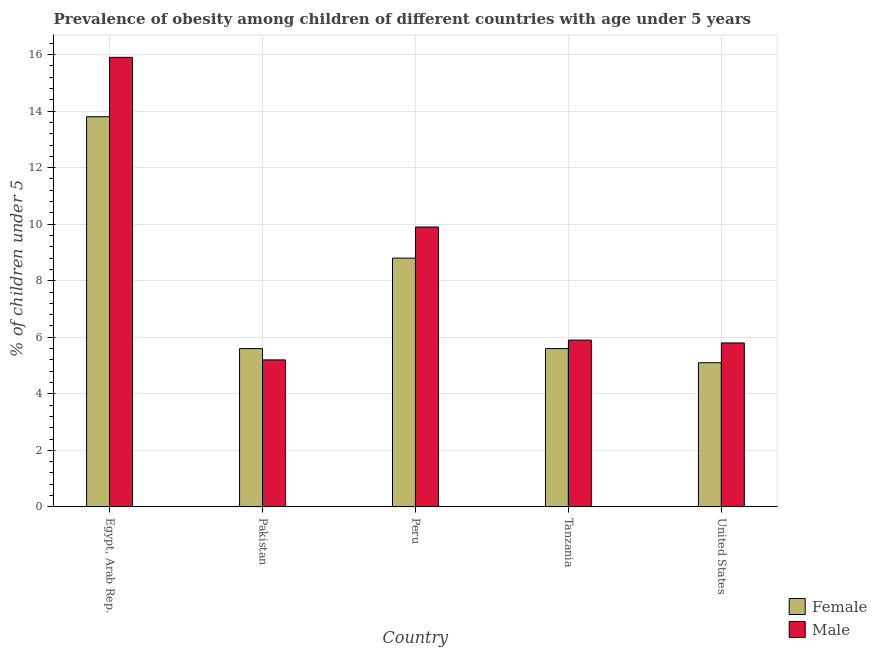How many bars are there on the 3rd tick from the left?
Ensure brevity in your answer.  2. How many bars are there on the 1st tick from the right?
Ensure brevity in your answer.  2. What is the label of the 4th group of bars from the left?
Ensure brevity in your answer.  Tanzania. In how many cases, is the number of bars for a given country not equal to the number of legend labels?
Offer a very short reply. 0. What is the percentage of obese female children in Tanzania?
Provide a short and direct response. 5.6. Across all countries, what is the maximum percentage of obese female children?
Keep it short and to the point. 13.8. Across all countries, what is the minimum percentage of obese female children?
Make the answer very short. 5.1. In which country was the percentage of obese female children maximum?
Your answer should be very brief. Egypt, Arab Rep. In which country was the percentage of obese female children minimum?
Give a very brief answer. United States. What is the total percentage of obese male children in the graph?
Keep it short and to the point. 42.7. What is the difference between the percentage of obese female children in Pakistan and that in Peru?
Give a very brief answer. -3.2. What is the difference between the percentage of obese male children in Peru and the percentage of obese female children in Tanzania?
Provide a succinct answer. 4.3. What is the average percentage of obese male children per country?
Offer a very short reply. 8.54. What is the difference between the percentage of obese female children and percentage of obese male children in Egypt, Arab Rep.?
Keep it short and to the point. -2.1. What is the ratio of the percentage of obese male children in Egypt, Arab Rep. to that in Pakistan?
Your answer should be compact. 3.06. What is the difference between the highest and the second highest percentage of obese male children?
Provide a succinct answer. 6. What is the difference between the highest and the lowest percentage of obese male children?
Your answer should be compact. 10.7. In how many countries, is the percentage of obese male children greater than the average percentage of obese male children taken over all countries?
Offer a very short reply. 2. Is the sum of the percentage of obese female children in Egypt, Arab Rep. and Tanzania greater than the maximum percentage of obese male children across all countries?
Your response must be concise. Yes. What does the 1st bar from the left in United States represents?
Offer a very short reply. Female. Are all the bars in the graph horizontal?
Ensure brevity in your answer.  No. How many countries are there in the graph?
Offer a terse response. 5. Does the graph contain grids?
Provide a short and direct response. Yes. Where does the legend appear in the graph?
Keep it short and to the point. Bottom right. How many legend labels are there?
Offer a very short reply. 2. How are the legend labels stacked?
Keep it short and to the point. Vertical. What is the title of the graph?
Your answer should be very brief. Prevalence of obesity among children of different countries with age under 5 years. What is the label or title of the Y-axis?
Give a very brief answer.  % of children under 5. What is the  % of children under 5 in Female in Egypt, Arab Rep.?
Your answer should be compact. 13.8. What is the  % of children under 5 of Male in Egypt, Arab Rep.?
Your response must be concise. 15.9. What is the  % of children under 5 of Female in Pakistan?
Your response must be concise. 5.6. What is the  % of children under 5 in Male in Pakistan?
Provide a succinct answer. 5.2. What is the  % of children under 5 of Female in Peru?
Give a very brief answer. 8.8. What is the  % of children under 5 of Male in Peru?
Give a very brief answer. 9.9. What is the  % of children under 5 in Female in Tanzania?
Offer a very short reply. 5.6. What is the  % of children under 5 in Male in Tanzania?
Your answer should be very brief. 5.9. What is the  % of children under 5 of Female in United States?
Your answer should be compact. 5.1. What is the  % of children under 5 of Male in United States?
Give a very brief answer. 5.8. Across all countries, what is the maximum  % of children under 5 in Female?
Provide a succinct answer. 13.8. Across all countries, what is the maximum  % of children under 5 of Male?
Offer a very short reply. 15.9. Across all countries, what is the minimum  % of children under 5 in Female?
Your answer should be very brief. 5.1. Across all countries, what is the minimum  % of children under 5 of Male?
Provide a short and direct response. 5.2. What is the total  % of children under 5 in Female in the graph?
Your answer should be very brief. 38.9. What is the total  % of children under 5 in Male in the graph?
Your answer should be very brief. 42.7. What is the difference between the  % of children under 5 of Female in Egypt, Arab Rep. and that in Pakistan?
Your answer should be compact. 8.2. What is the difference between the  % of children under 5 in Male in Egypt, Arab Rep. and that in Pakistan?
Your response must be concise. 10.7. What is the difference between the  % of children under 5 of Female in Egypt, Arab Rep. and that in Peru?
Your answer should be compact. 5. What is the difference between the  % of children under 5 in Male in Egypt, Arab Rep. and that in Tanzania?
Make the answer very short. 10. What is the difference between the  % of children under 5 of Female in Egypt, Arab Rep. and that in United States?
Give a very brief answer. 8.7. What is the difference between the  % of children under 5 of Male in Egypt, Arab Rep. and that in United States?
Keep it short and to the point. 10.1. What is the difference between the  % of children under 5 of Female in Pakistan and that in United States?
Your answer should be compact. 0.5. What is the difference between the  % of children under 5 of Male in Pakistan and that in United States?
Ensure brevity in your answer.  -0.6. What is the difference between the  % of children under 5 of Male in Peru and that in Tanzania?
Give a very brief answer. 4. What is the difference between the  % of children under 5 in Female in Tanzania and that in United States?
Offer a very short reply. 0.5. What is the difference between the  % of children under 5 of Female in Egypt, Arab Rep. and the  % of children under 5 of Male in Pakistan?
Provide a short and direct response. 8.6. What is the difference between the  % of children under 5 of Female in Egypt, Arab Rep. and the  % of children under 5 of Male in United States?
Keep it short and to the point. 8. What is the difference between the  % of children under 5 in Female in Pakistan and the  % of children under 5 in Male in Peru?
Give a very brief answer. -4.3. What is the average  % of children under 5 in Female per country?
Offer a very short reply. 7.78. What is the average  % of children under 5 of Male per country?
Your answer should be compact. 8.54. What is the difference between the  % of children under 5 in Female and  % of children under 5 in Male in Pakistan?
Offer a terse response. 0.4. What is the difference between the  % of children under 5 of Female and  % of children under 5 of Male in United States?
Your answer should be compact. -0.7. What is the ratio of the  % of children under 5 of Female in Egypt, Arab Rep. to that in Pakistan?
Your answer should be compact. 2.46. What is the ratio of the  % of children under 5 in Male in Egypt, Arab Rep. to that in Pakistan?
Provide a short and direct response. 3.06. What is the ratio of the  % of children under 5 of Female in Egypt, Arab Rep. to that in Peru?
Provide a succinct answer. 1.57. What is the ratio of the  % of children under 5 in Male in Egypt, Arab Rep. to that in Peru?
Make the answer very short. 1.61. What is the ratio of the  % of children under 5 in Female in Egypt, Arab Rep. to that in Tanzania?
Make the answer very short. 2.46. What is the ratio of the  % of children under 5 of Male in Egypt, Arab Rep. to that in Tanzania?
Give a very brief answer. 2.69. What is the ratio of the  % of children under 5 in Female in Egypt, Arab Rep. to that in United States?
Give a very brief answer. 2.71. What is the ratio of the  % of children under 5 in Male in Egypt, Arab Rep. to that in United States?
Make the answer very short. 2.74. What is the ratio of the  % of children under 5 of Female in Pakistan to that in Peru?
Offer a terse response. 0.64. What is the ratio of the  % of children under 5 of Male in Pakistan to that in Peru?
Offer a very short reply. 0.53. What is the ratio of the  % of children under 5 of Male in Pakistan to that in Tanzania?
Offer a terse response. 0.88. What is the ratio of the  % of children under 5 of Female in Pakistan to that in United States?
Keep it short and to the point. 1.1. What is the ratio of the  % of children under 5 of Male in Pakistan to that in United States?
Offer a terse response. 0.9. What is the ratio of the  % of children under 5 in Female in Peru to that in Tanzania?
Your answer should be very brief. 1.57. What is the ratio of the  % of children under 5 in Male in Peru to that in Tanzania?
Your answer should be very brief. 1.68. What is the ratio of the  % of children under 5 of Female in Peru to that in United States?
Your response must be concise. 1.73. What is the ratio of the  % of children under 5 in Male in Peru to that in United States?
Provide a succinct answer. 1.71. What is the ratio of the  % of children under 5 of Female in Tanzania to that in United States?
Provide a short and direct response. 1.1. What is the ratio of the  % of children under 5 of Male in Tanzania to that in United States?
Your answer should be compact. 1.02. What is the difference between the highest and the second highest  % of children under 5 in Female?
Give a very brief answer. 5. What is the difference between the highest and the second highest  % of children under 5 in Male?
Ensure brevity in your answer.  6. What is the difference between the highest and the lowest  % of children under 5 of Female?
Offer a very short reply. 8.7. What is the difference between the highest and the lowest  % of children under 5 of Male?
Your answer should be very brief. 10.7. 